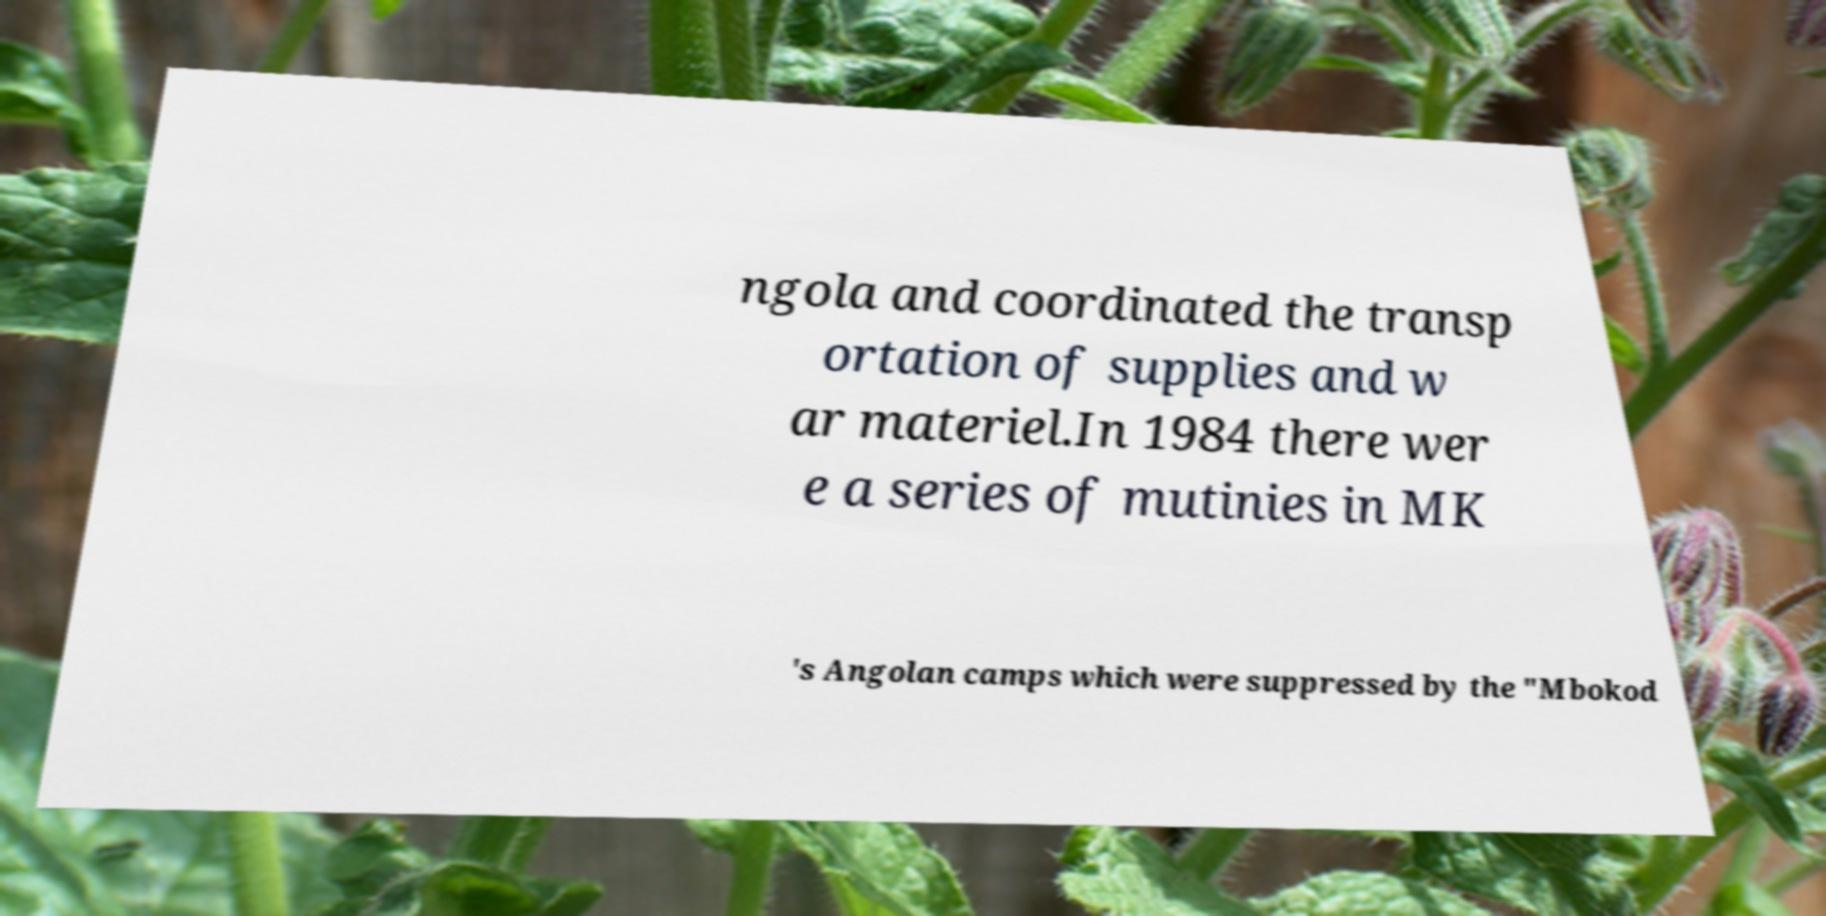I need the written content from this picture converted into text. Can you do that? ngola and coordinated the transp ortation of supplies and w ar materiel.In 1984 there wer e a series of mutinies in MK 's Angolan camps which were suppressed by the "Mbokod 